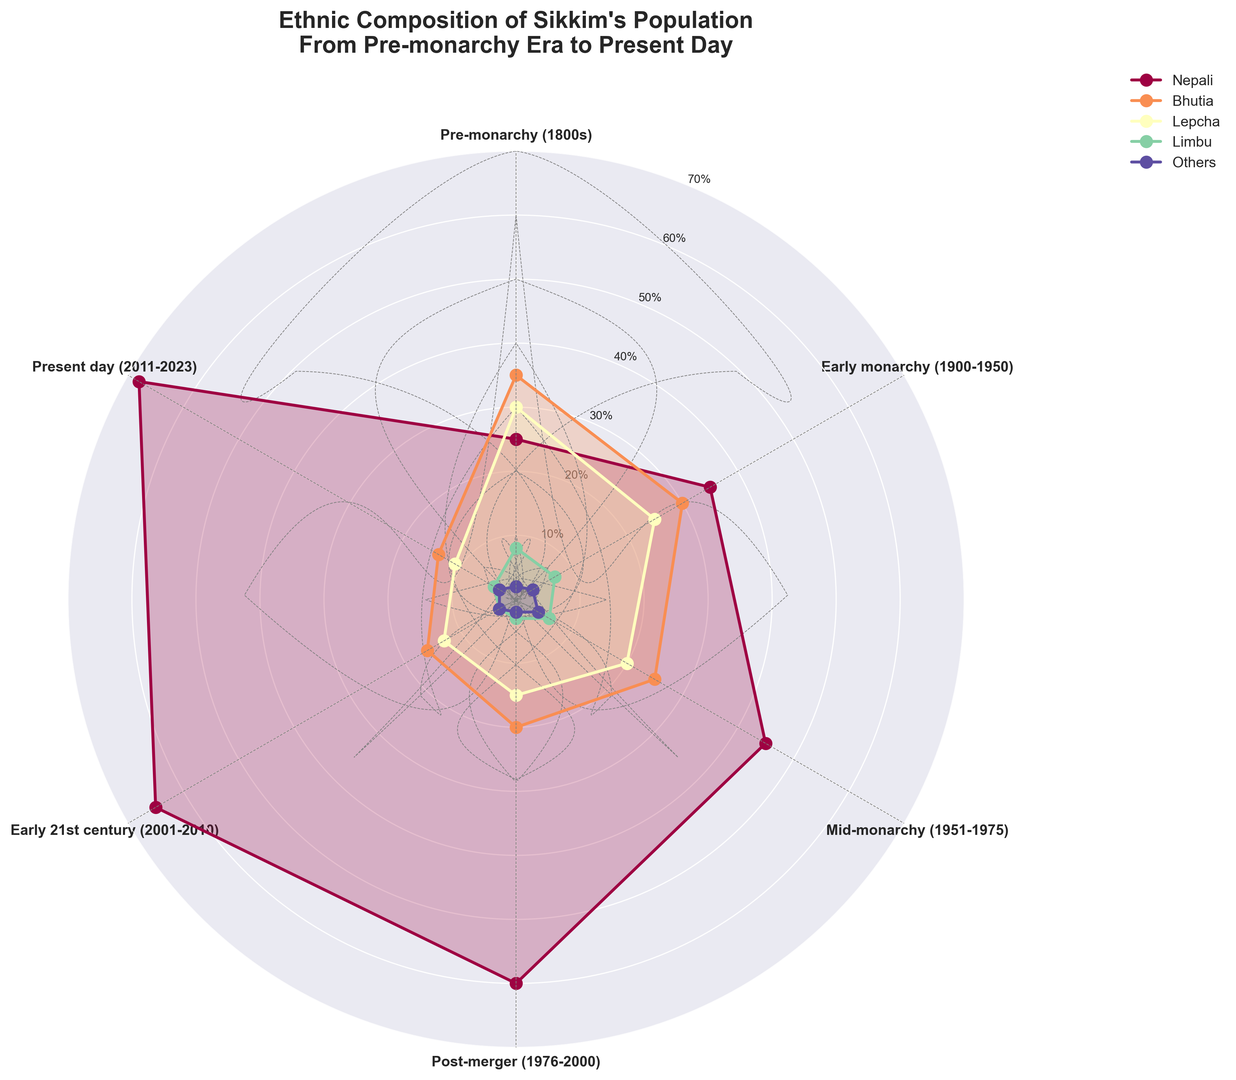What era shows the highest proportion of Nepali population? Locate the Nepali population line on the rose chart and identify the era where it reaches its maximum value (the farthest point from the center). This occurs in the "Present day (2011-2023)" era.
Answer: Present day (2011-2023) During which era does the Bhutia population experience the most significant decrease? Compare the Bhutia population percentages across different eras and identify the era with the most significant decrease. There is a noticeable drop from the "Early 21st century (2001-2010)" to the "Present day (2011-2023)".
Answer: Present day (2011-2023) How does the proportion of Lepcha population in the Early monarchy (1900-1950) compare to the Pre-monarchy (1800s)? Find the Lepcha population percentages in the Early monarchy and Pre-monarchy eras and compare them. The proportion decreases from 30% in Pre-monarchy to 25% in Early monarchy.
Answer: Decreased What's the difference in proportion between the Nepali and Bhutia populations in the Mid-monarchy (1951-1975)? Subtract the Bhutia population percentage from the Nepali population percentage for the Mid-monarchy era (1951-1975). The difference is 45% - 25%.
Answer: 20% What ethnic group had the smallest change in proportion from the Pre-monarchy (1800s) to Present day (2011-2023)? Calculate the absolute change for each ethnic group from Pre-monarchy to Present day and determine the smallest value. The "Others" group changed from 2% to 3%, a difference of 1%.
Answer: Others During which era did the Limbu population have the lowest proportion? Identify the Limbu proportion in each era and determine the lowest value, which occurs in the "Post-merger (1976-2000)" era.
Answer: Post-merger (1976-2000) Compare the trends of Bhutia and Lepcha populations from Early monarchy (1900-1950) to Present day (2011-2023). Examine the changes in proportions of Bhutia and Lepcha populations across the eras. Both show a downward trend, but the Bhutia population decreases more steeply than the Lepcha population.
Answer: Both decrease, Bhutia more steeply What is the average percentage of the Nepali population over all the eras? Add the Nepali population percentages for all eras and divide by the number of eras: (25+35+45+60+65+68)/6 = 49.67%.
Answer: 49.67% Which ethnic group shows the most consistent population proportion across all eras? Analyze the stability of population proportions for each ethnic group over time. The "Others" group remains the most stable with minimal fluctuation from 2% to 3%.
Answer: Others Which era had the highest combined proportion of Lepcha and Limbu populations? Add the Lepcha and Limbu population percentages for each era and identify the highest combined value. Pre-monarchy (1800s) has the highest with 30% + 8% = 38%.
Answer: Pre-monarchy (1800s) 